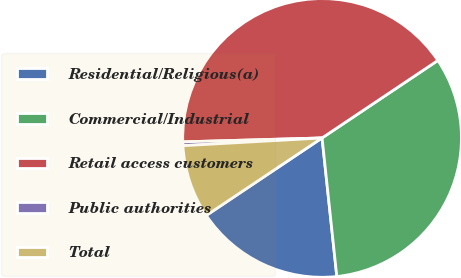Convert chart to OTSL. <chart><loc_0><loc_0><loc_500><loc_500><pie_chart><fcel>Residential/Religious(a)<fcel>Commercial/Industrial<fcel>Retail access customers<fcel>Public authorities<fcel>Total<nl><fcel>17.3%<fcel>32.7%<fcel>41.06%<fcel>0.44%<fcel>8.5%<nl></chart> 